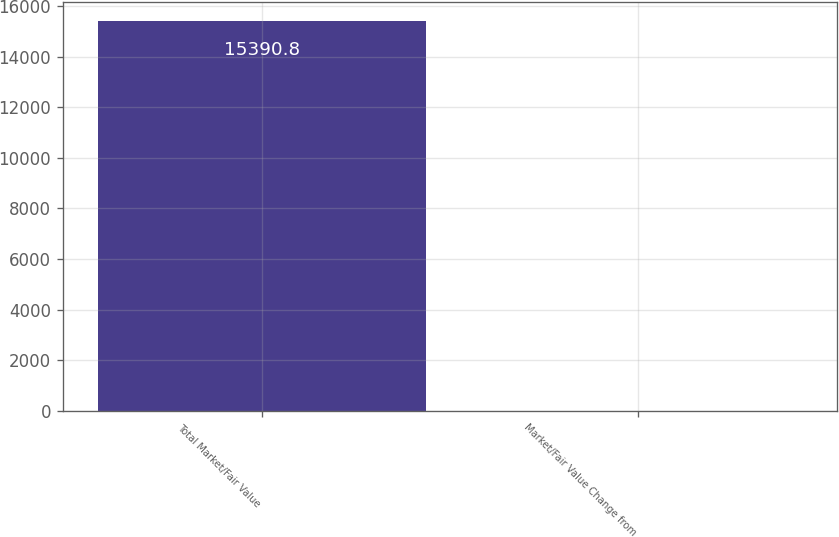<chart> <loc_0><loc_0><loc_500><loc_500><bar_chart><fcel>Total Market/Fair Value<fcel>Market/Fair Value Change from<nl><fcel>15390.8<fcel>5.9<nl></chart> 